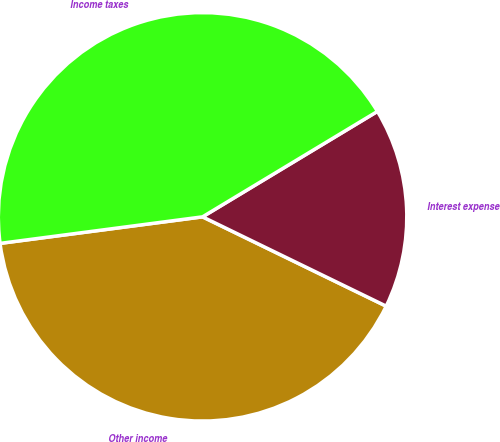Convert chart. <chart><loc_0><loc_0><loc_500><loc_500><pie_chart><fcel>Other income<fcel>Interest expense<fcel>Income taxes<nl><fcel>40.72%<fcel>15.84%<fcel>43.44%<nl></chart> 